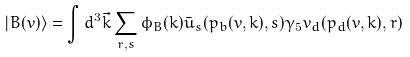Convert formula to latex. <formula><loc_0><loc_0><loc_500><loc_500>| B ( v ) \rangle = \int d ^ { 3 } \vec { k } \sum _ { { \sl r } , { \sl s } } \phi _ { B } ( { k } ) { \bar { u } _ { \sl s } } ( p _ { b } ( v , k ) , s ) \gamma _ { 5 } v _ { d } ( p _ { d } ( v , k ) , { r } )</formula> 